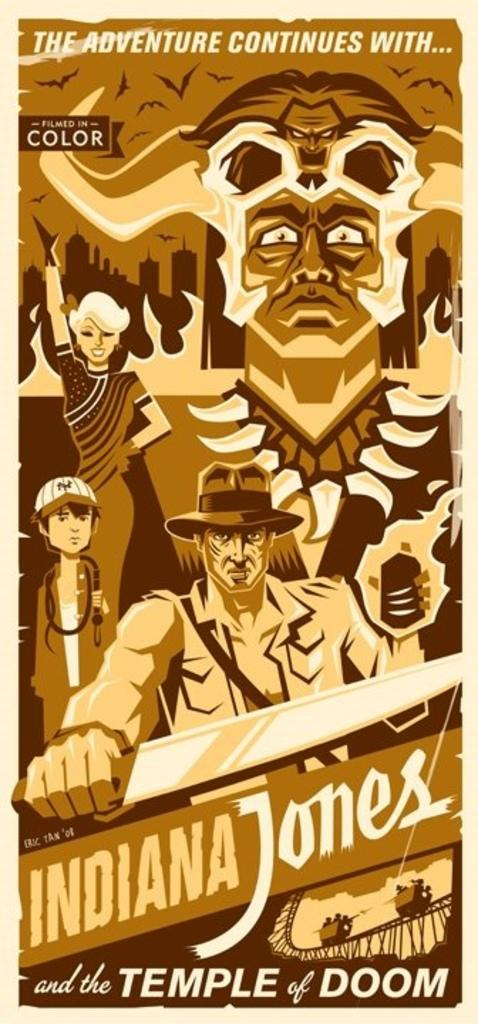Provide a one-sentence caption for the provided image. An animated Poster of the movie of Indiana Jones and the Temple of Doom. 